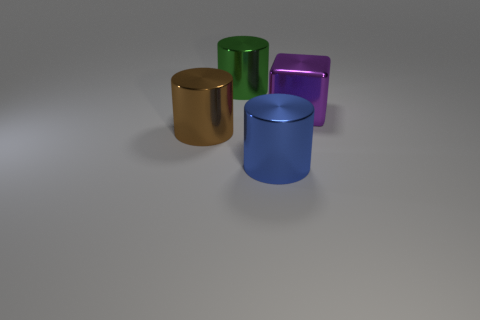Are there fewer big cyan blocks than shiny things?
Your response must be concise. Yes. What number of blue objects have the same size as the brown shiny cylinder?
Provide a short and direct response. 1. Is the big brown thing made of the same material as the green object?
Keep it short and to the point. Yes. What number of big blue objects are the same shape as the large brown object?
Offer a terse response. 1. The brown thing that is made of the same material as the blue cylinder is what shape?
Your answer should be very brief. Cylinder. There is a big metallic thing that is behind the big object right of the blue metal cylinder; what is its color?
Your answer should be compact. Green. There is a big cylinder behind the big metallic thing right of the blue cylinder; is there a big blue cylinder that is right of it?
Keep it short and to the point. Yes. What number of other things are there of the same color as the large block?
Your response must be concise. 0. What number of big metal objects are in front of the big purple cube and behind the large blue object?
Ensure brevity in your answer.  1. There is a big green thing; what shape is it?
Provide a succinct answer. Cylinder. 